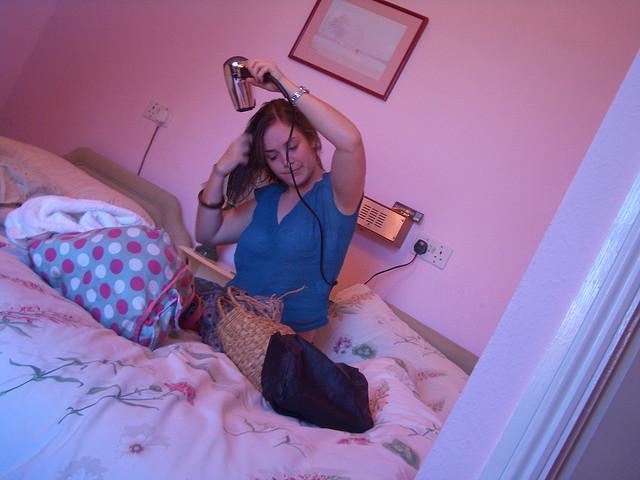How many handbags are there?
Give a very brief answer. 2. 